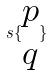<formula> <loc_0><loc_0><loc_500><loc_500>s \{ \begin{matrix} p \\ q \end{matrix} \}</formula> 